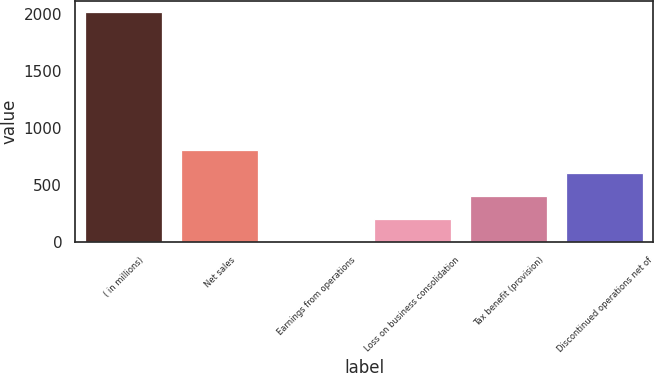Convert chart. <chart><loc_0><loc_0><loc_500><loc_500><bar_chart><fcel>( in millions)<fcel>Net sales<fcel>Earnings from operations<fcel>Loss on business consolidation<fcel>Tax benefit (provision)<fcel>Discontinued operations net of<nl><fcel>2010<fcel>806.1<fcel>3.5<fcel>204.15<fcel>404.8<fcel>605.45<nl></chart> 